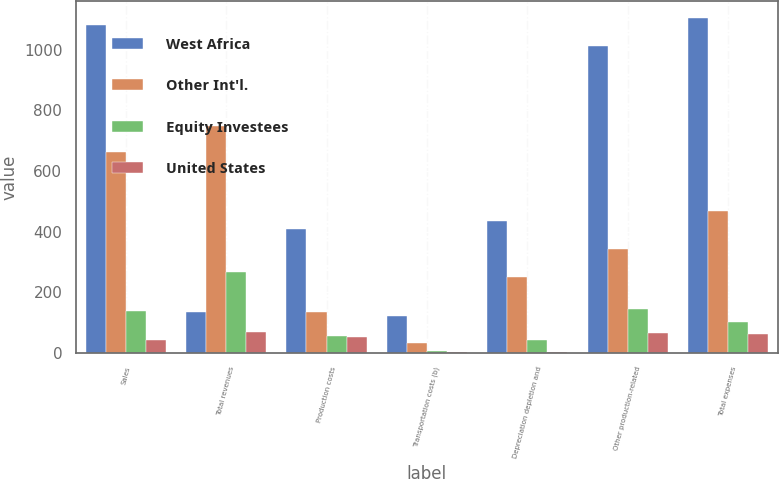Convert chart. <chart><loc_0><loc_0><loc_500><loc_500><stacked_bar_chart><ecel><fcel>Sales<fcel>Total revenues<fcel>Production costs<fcel>Transportation costs (b)<fcel>Depreciation depletion and<fcel>Other production-related<fcel>Total expenses<nl><fcel>West Africa<fcel>1081<fcel>136<fcel>410<fcel>120<fcel>436<fcel>1013<fcel>1106<nl><fcel>Other Int'l.<fcel>662<fcel>747<fcel>136<fcel>32<fcel>251<fcel>343<fcel>469<nl><fcel>Equity Investees<fcel>139<fcel>265<fcel>55<fcel>5<fcel>41<fcel>144<fcel>102<nl><fcel>United States<fcel>43<fcel>67<fcel>53<fcel>3<fcel>2<fcel>64<fcel>63<nl></chart> 